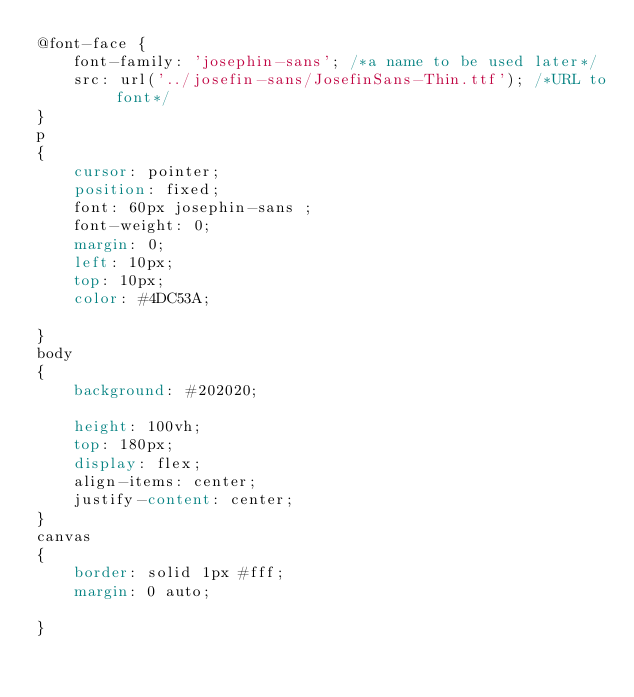<code> <loc_0><loc_0><loc_500><loc_500><_CSS_>@font-face {
    font-family: 'josephin-sans'; /*a name to be used later*/
    src: url('../josefin-sans/JosefinSans-Thin.ttf'); /*URL to font*/
}
p
{
    cursor: pointer;
    position: fixed;
    font: 60px josephin-sans ;
    font-weight: 0;
    margin: 0;
    left: 10px;
    top: 10px;
    color: #4DC53A;
    
}
body 
{
    background: #202020;
    
    height: 100vh;
    top: 180px;
    display: flex;
    align-items: center;
    justify-content: center;
}
canvas
{
    border: solid 1px #fff;
    margin: 0 auto;
    
}
</code> 